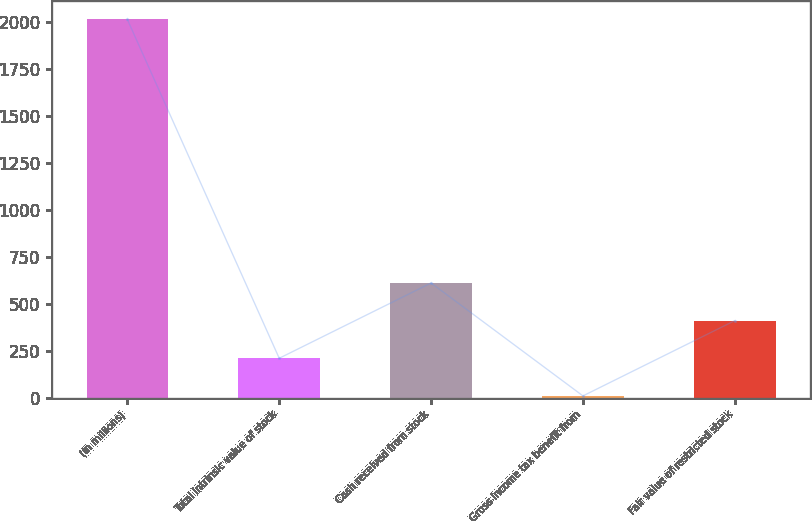Convert chart to OTSL. <chart><loc_0><loc_0><loc_500><loc_500><bar_chart><fcel>(In millions)<fcel>Total intrinsic value of stock<fcel>Cash received from stock<fcel>Gross income tax benefit from<fcel>Fair value of restricted stock<nl><fcel>2013<fcel>210.3<fcel>610.9<fcel>10<fcel>410.6<nl></chart> 